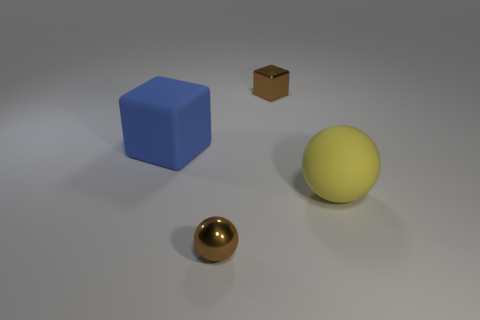There is a shiny object that is the same color as the tiny metal ball; what shape is it?
Ensure brevity in your answer.  Cube. The metal sphere that is the same color as the tiny metal cube is what size?
Ensure brevity in your answer.  Small. What number of small metallic blocks are the same color as the small sphere?
Make the answer very short. 1. There is a small thing that is the same color as the small block; what material is it?
Provide a succinct answer. Metal. Is the number of large blue rubber cubes less than the number of tiny red rubber cylinders?
Your answer should be compact. No. There is a ball that is the same size as the blue rubber thing; what is it made of?
Provide a short and direct response. Rubber. What number of objects are either brown spheres or big red metallic blocks?
Your answer should be very brief. 1. What number of things are to the right of the small brown sphere and in front of the blue rubber cube?
Make the answer very short. 1. Is the number of large blue blocks to the right of the small sphere less than the number of big blue things?
Provide a short and direct response. Yes. What is the shape of the object that is the same size as the blue rubber cube?
Offer a very short reply. Sphere. 